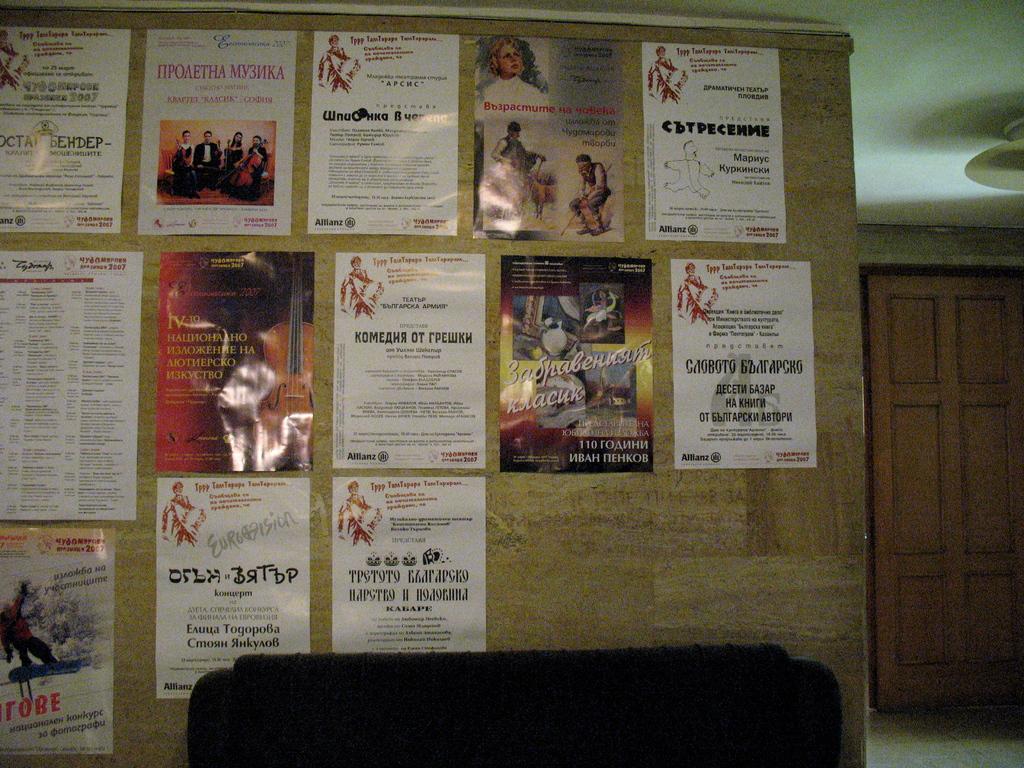Can you be able to see and read what is on the board?
Provide a short and direct response. Yes. 